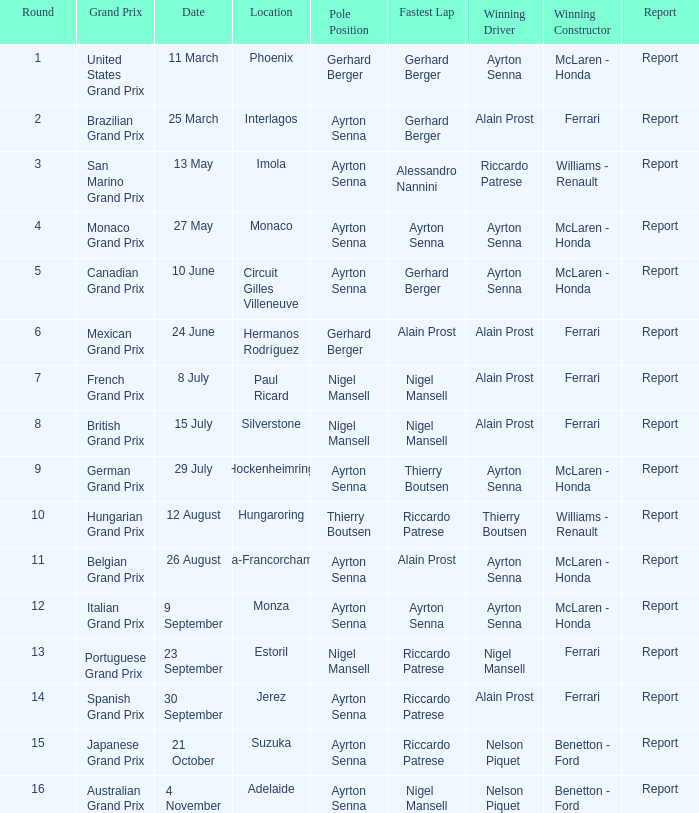What was the constructor when riccardo patrese was the winning driver? Williams - Renault. 